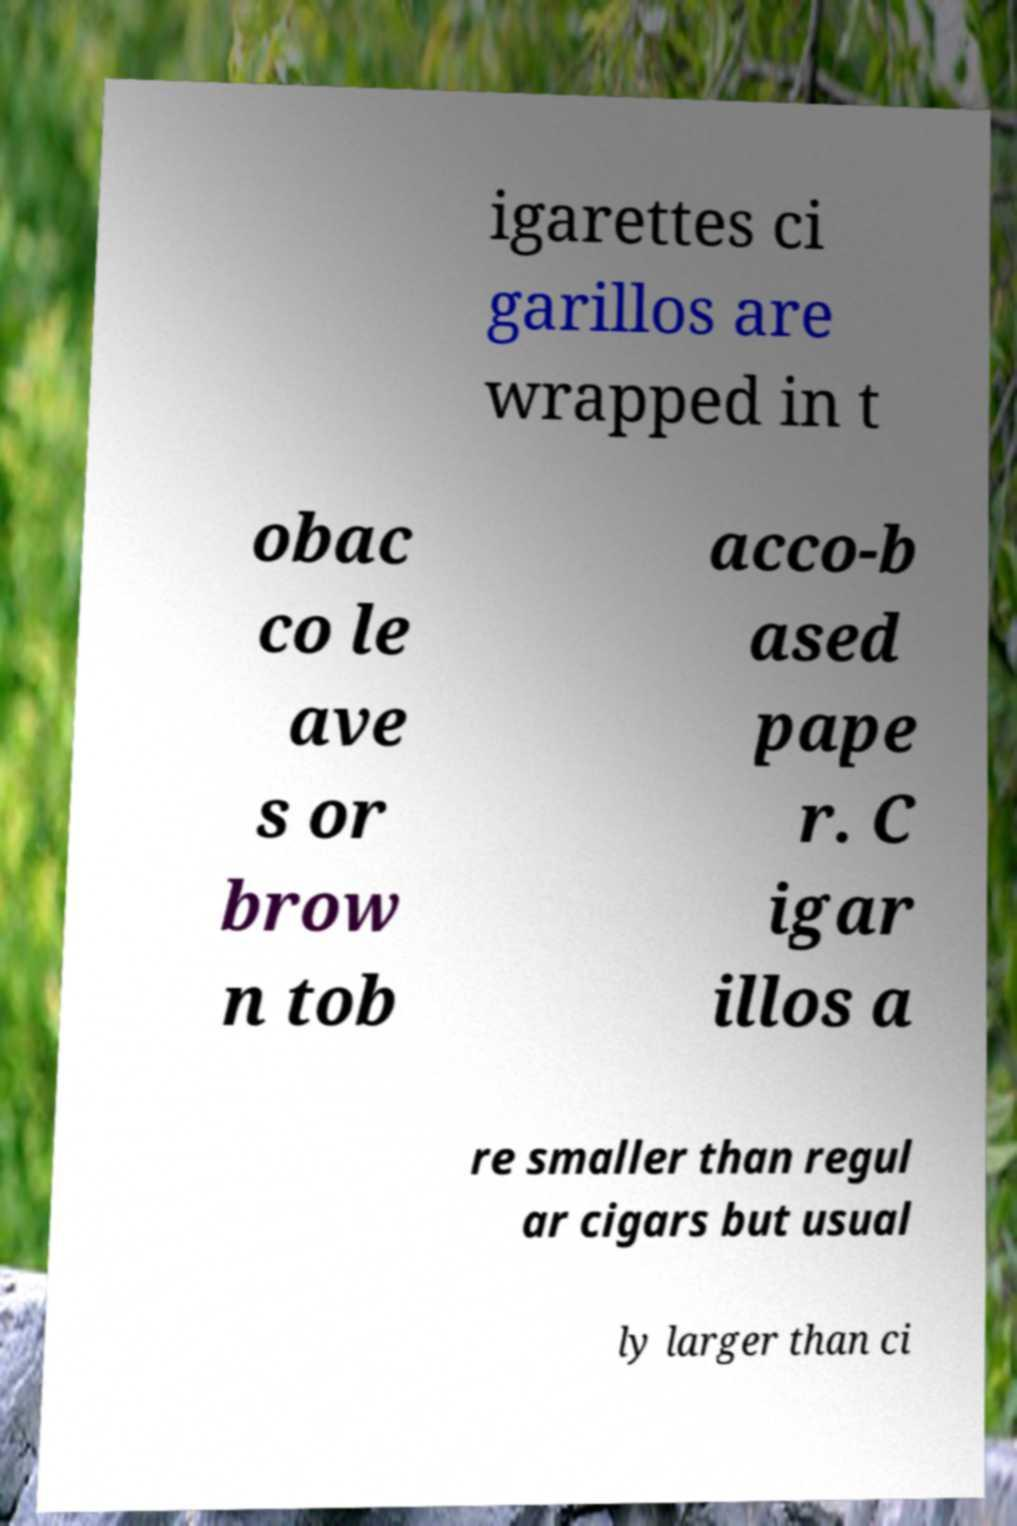Please identify and transcribe the text found in this image. igarettes ci garillos are wrapped in t obac co le ave s or brow n tob acco-b ased pape r. C igar illos a re smaller than regul ar cigars but usual ly larger than ci 